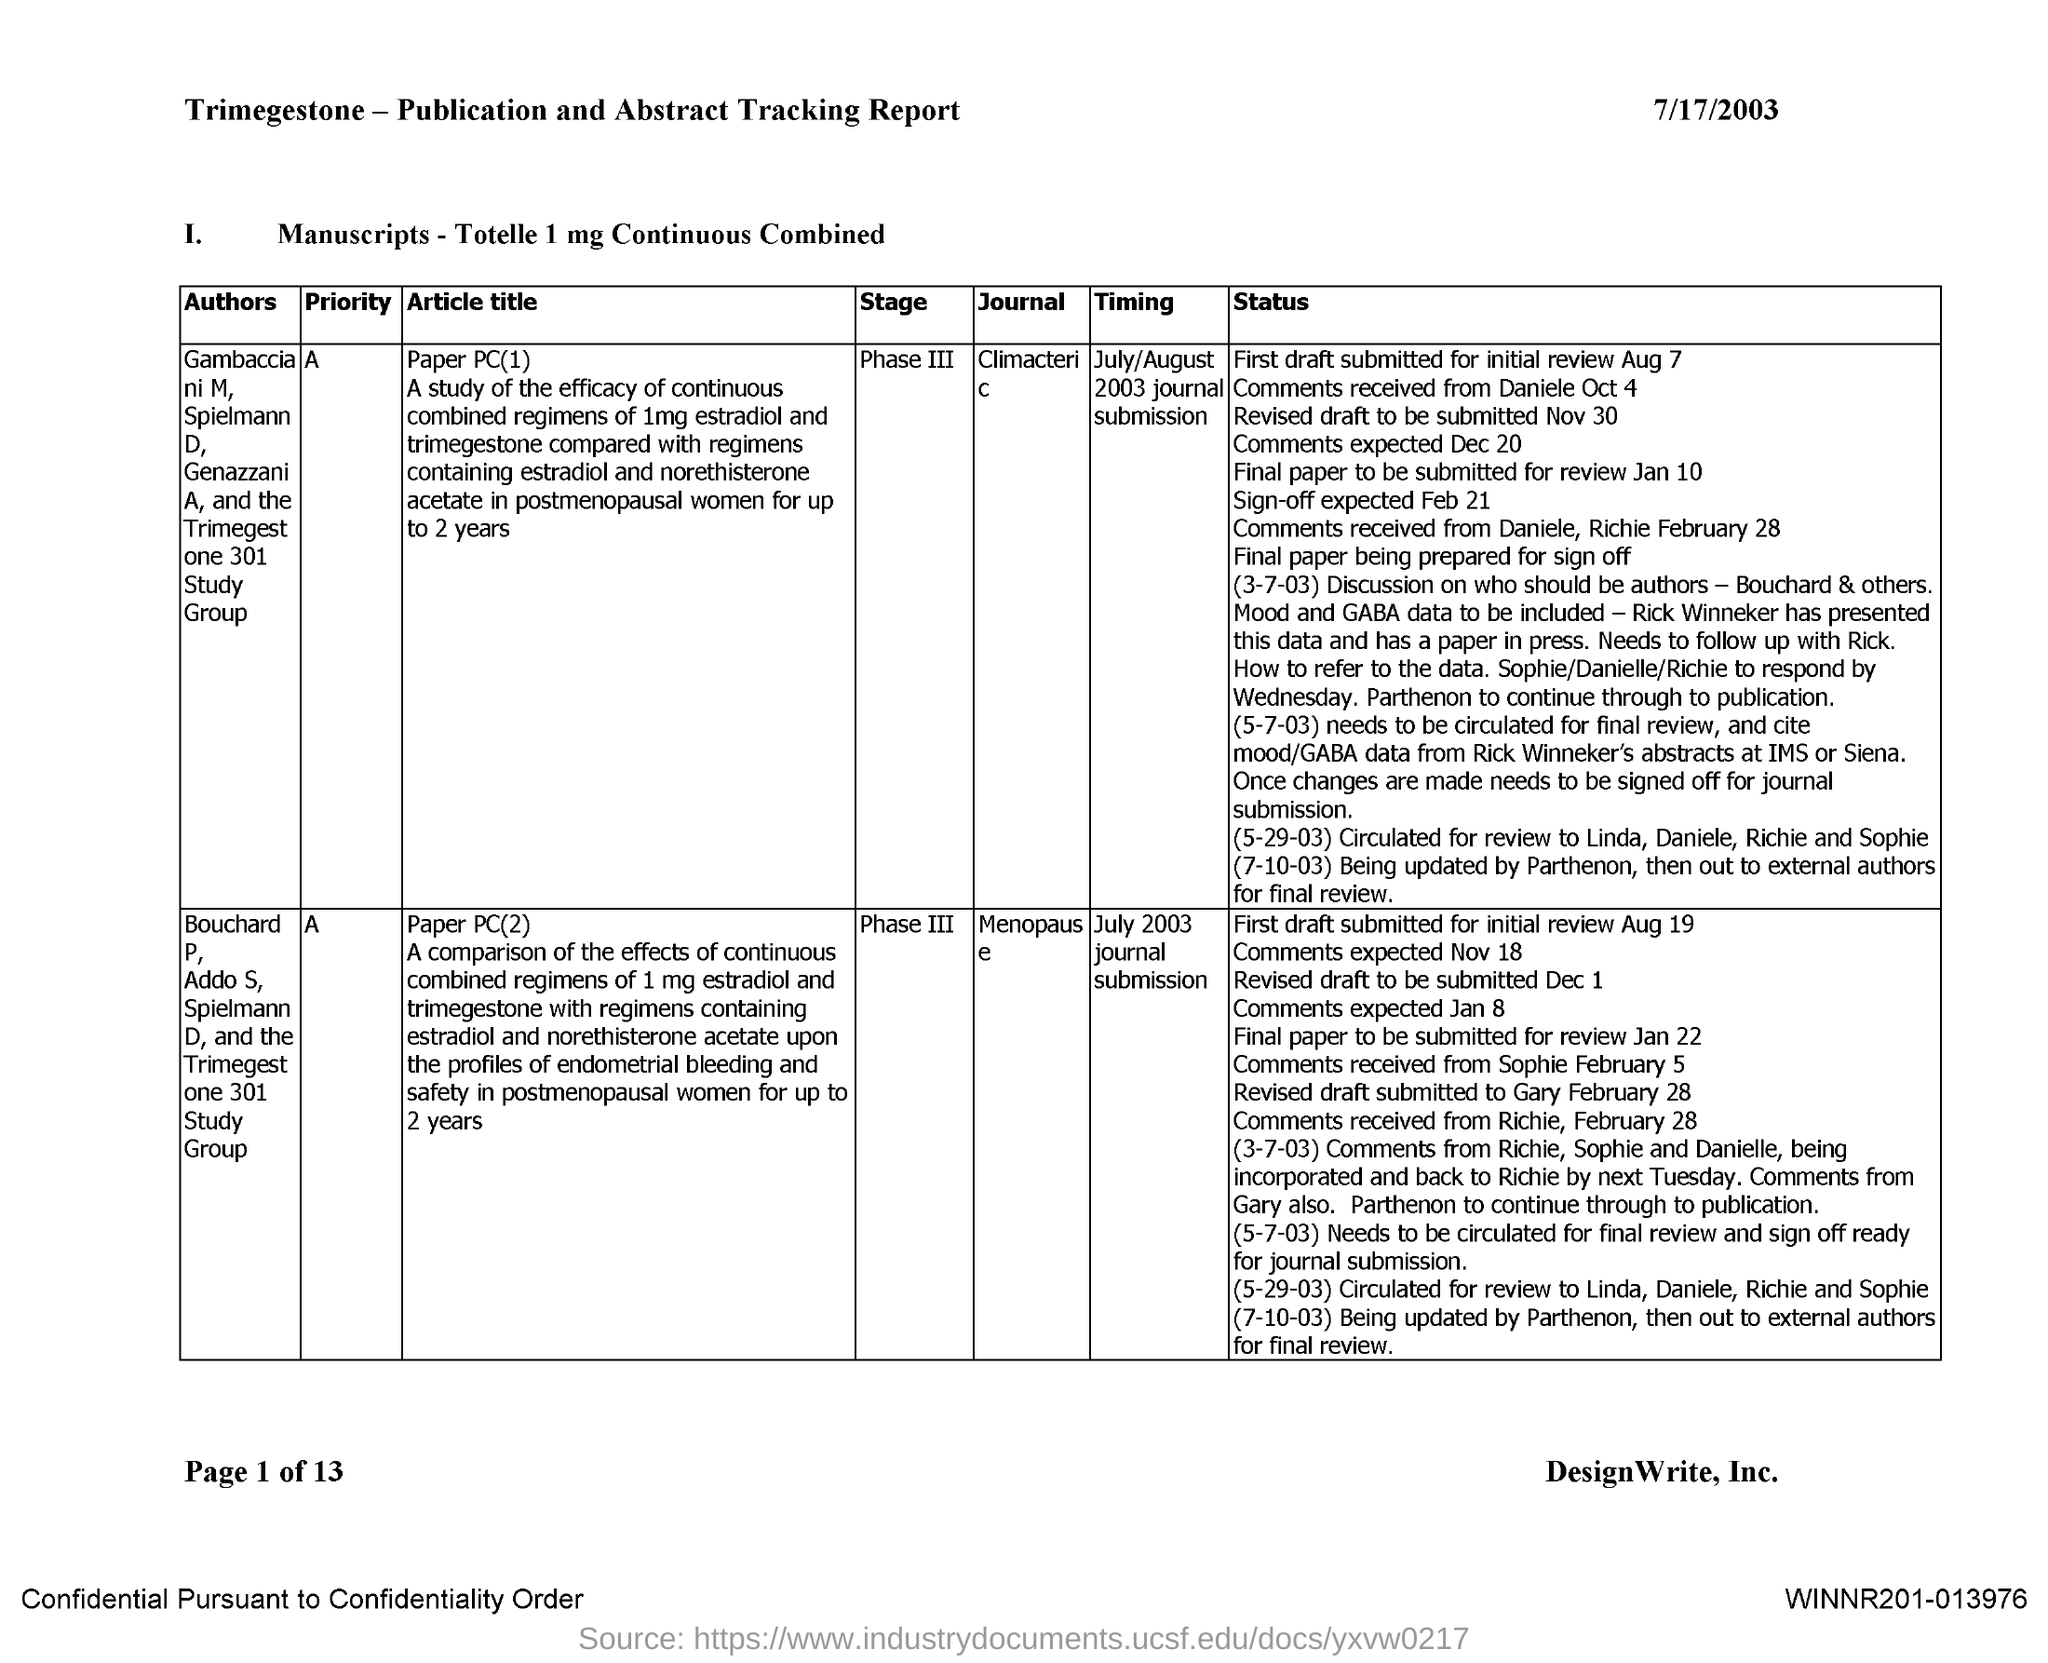What is the name of the journal whose article title is paper PC(1)?
Provide a short and direct response. Climacteric. What is the name of the journal whose article title is paper PC(2)?
Make the answer very short. Menopause. 